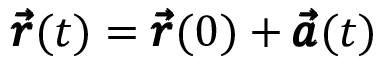<formula> <loc_0><loc_0><loc_500><loc_500>\pm b { \vec { r } } ( t ) = \pm b { \vec { r } } ( 0 ) + \pm b { \vec { a } } ( t )</formula> 